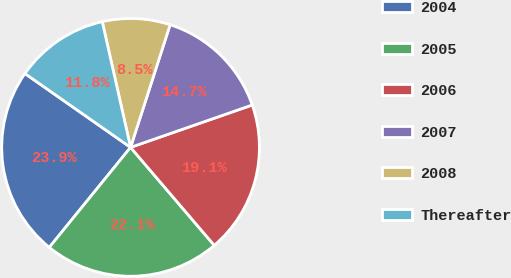Convert chart to OTSL. <chart><loc_0><loc_0><loc_500><loc_500><pie_chart><fcel>2004<fcel>2005<fcel>2006<fcel>2007<fcel>2008<fcel>Thereafter<nl><fcel>23.85%<fcel>22.11%<fcel>19.08%<fcel>14.7%<fcel>8.49%<fcel>11.76%<nl></chart> 